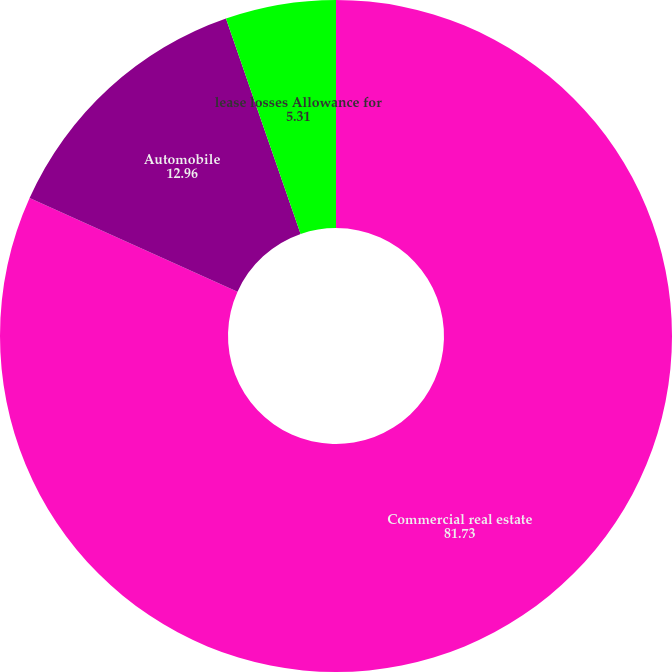<chart> <loc_0><loc_0><loc_500><loc_500><pie_chart><fcel>Commercial real estate<fcel>Automobile<fcel>lease losses Allowance for<nl><fcel>81.73%<fcel>12.96%<fcel>5.31%<nl></chart> 